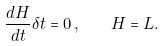Convert formula to latex. <formula><loc_0><loc_0><loc_500><loc_500>\frac { d H } { d t } \delta t = 0 \, , \quad H = L .</formula> 